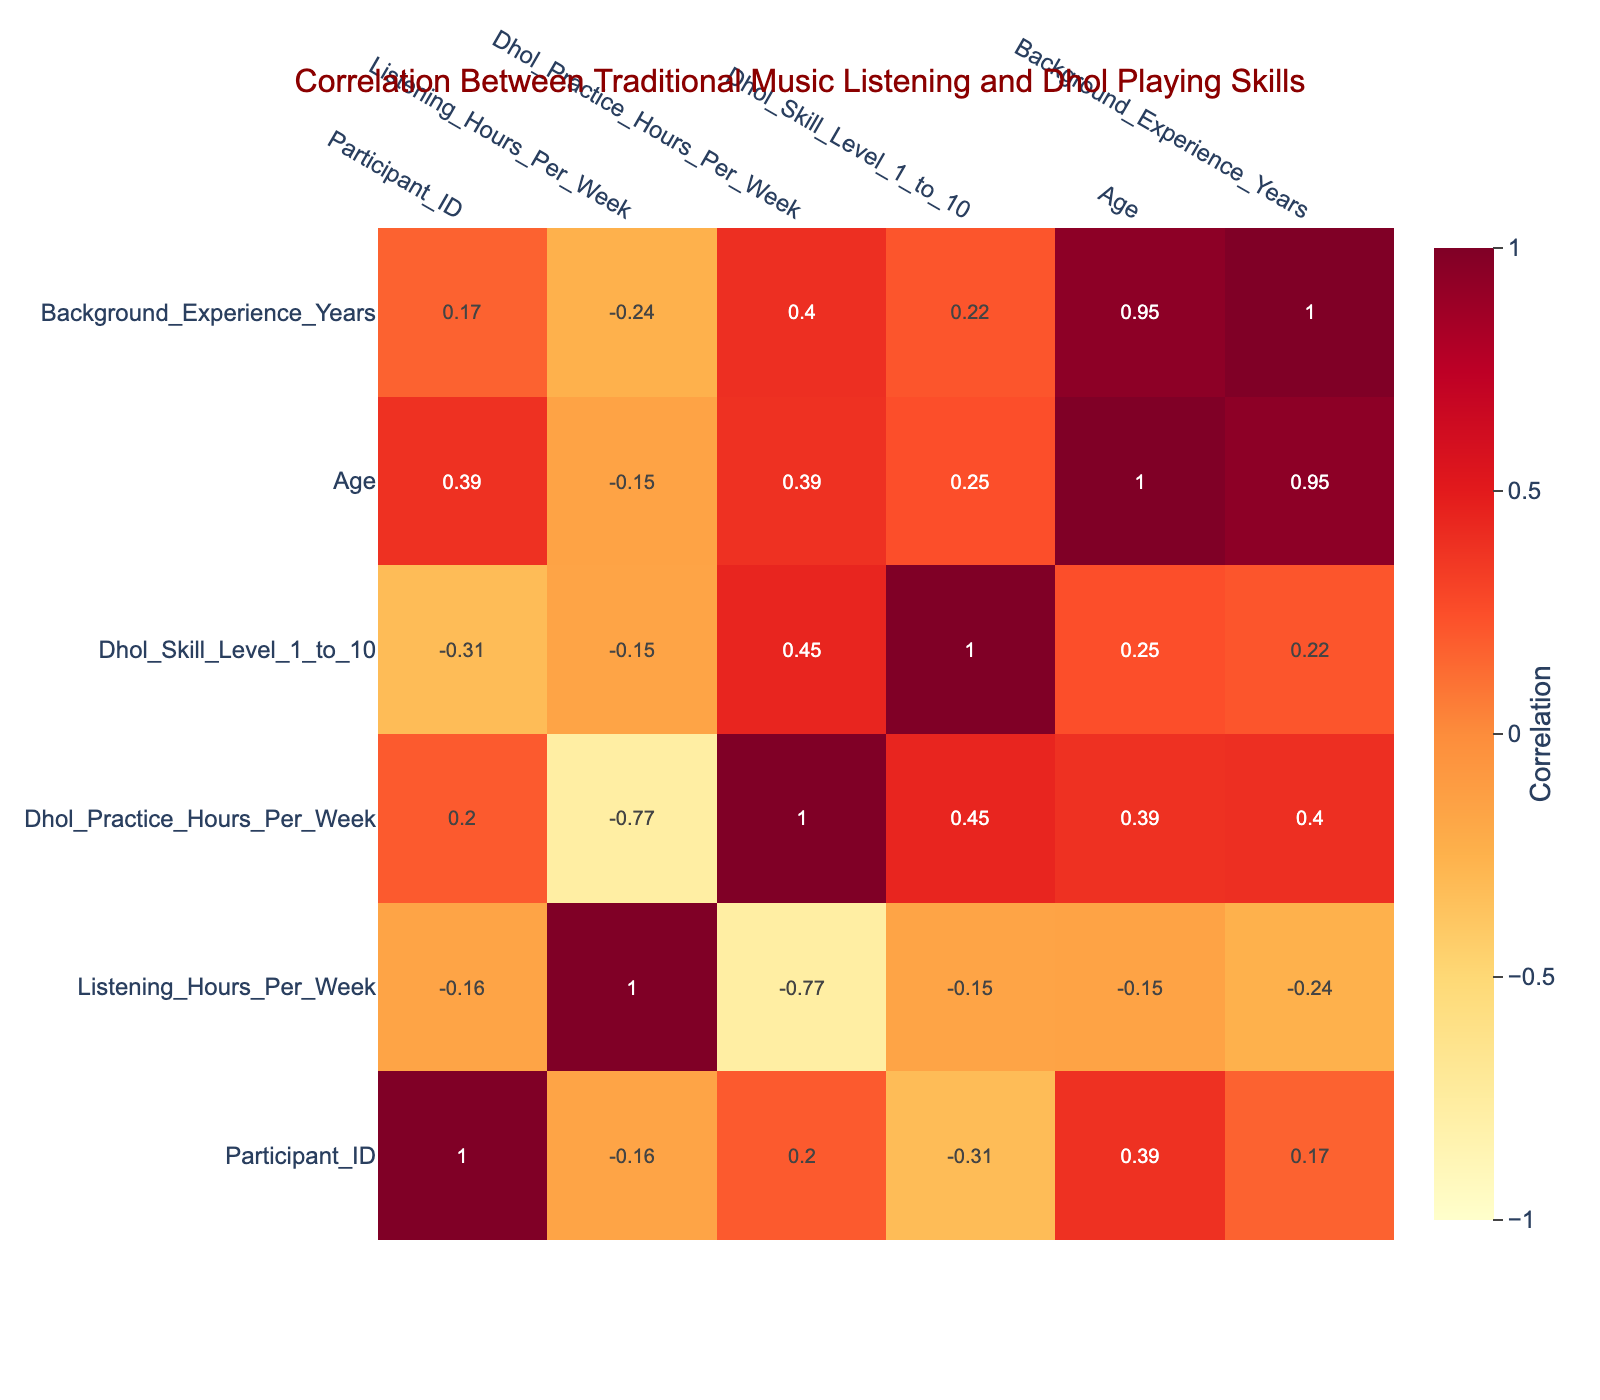What is the correlation coefficient between Listening Hours Per Week and Dhol Skill Level? To find this, we look at the correlation matrix in the table. The value corresponding to the intersection of 'Listening_Hours_Per_Week' and 'Dhol_Skill_Level' reveals the correlation coefficient.
Answer: [correlation coefficient value] What is the Dhol Skill Level of the participant who listens to music for 20 hours a week? We refer to the row where Listening_Hours_Per_Week equals 20. Here, Participant 5 has a Dhol Skill Level of 10.
Answer: 10 Is there a positive correlation between Dhol Practice Hours Per Week and Dhol Skill Level? By examining the correlation matrix, we look at the value for 'Dhol_Practice_Hours_Per_Week' and 'Dhol_Skill_Level'. If the value is greater than 0, it indicates a positive correlation.
Answer: Yes What is the average age of participants who have more than 15 Listening Hours Per Week? First, we identify participants with Listening_Hours_Per_Week greater than 15 (Participants 2, 5, 7, and 9). Their ages are 30, 35, 23, and 32. We sum these ages (30 + 35 + 23 + 32 = 120) and divide by the number of participants (4), resulting in an average of 30.
Answer: 30 What is the highest Dhol Skill Level reported in the table? We scan the Dhol Skill Level column to find the maximum value. The highest value noted is 10, belonging to Participant 5.
Answer: 10 Do all participants over the age of 30 have a Dhol Skill Level of at least 6? Assessing the data, the participants over 30 are Participants 5, 8, and 9. Their skill levels are 10, 8, and 7, respectively, which all satisfy the condition of being at least 6.
Answer: Yes What is the total Dhol Practice Hours Per Week for participants who reported a Dhol Skill Level of 9? We locate participants with a Dhol Skill Level of 9, which are Participants 3 and 6. Their Dhol Practice Hours are 20 and 25, respectively. Summing these values gives 20 + 25 = 45.
Answer: 45 Which participant has the least Listening Hours but the most Dhol Practice Hours? We check the Listening Hours column for the minimum value and find that Participant 8 has 0 Listening Hours while having 30 Dhol Practice Hours, which is the highest in that condition.
Answer: Participant 8 What is the difference in average Dhol Practice Hours between participants with more than 10 Listening Hours per Week and those with 10 or less? We calculate the average Dhol Practice Hours for both groups. Participants with more than 10 Listening Hours (Participants 1, 2, 5, 6, 9) average Dhol Practice Hours: (12 + 8 + 10 + 25 + 18)/5 = 14.6. Participants with 10 or less (Participants 3, 4, 7, 8, 10): (20 + 15 + 5 + 30 + 10)/5 = 14. The difference is 14.6 - 14 = 0.6.
Answer: 0.6 